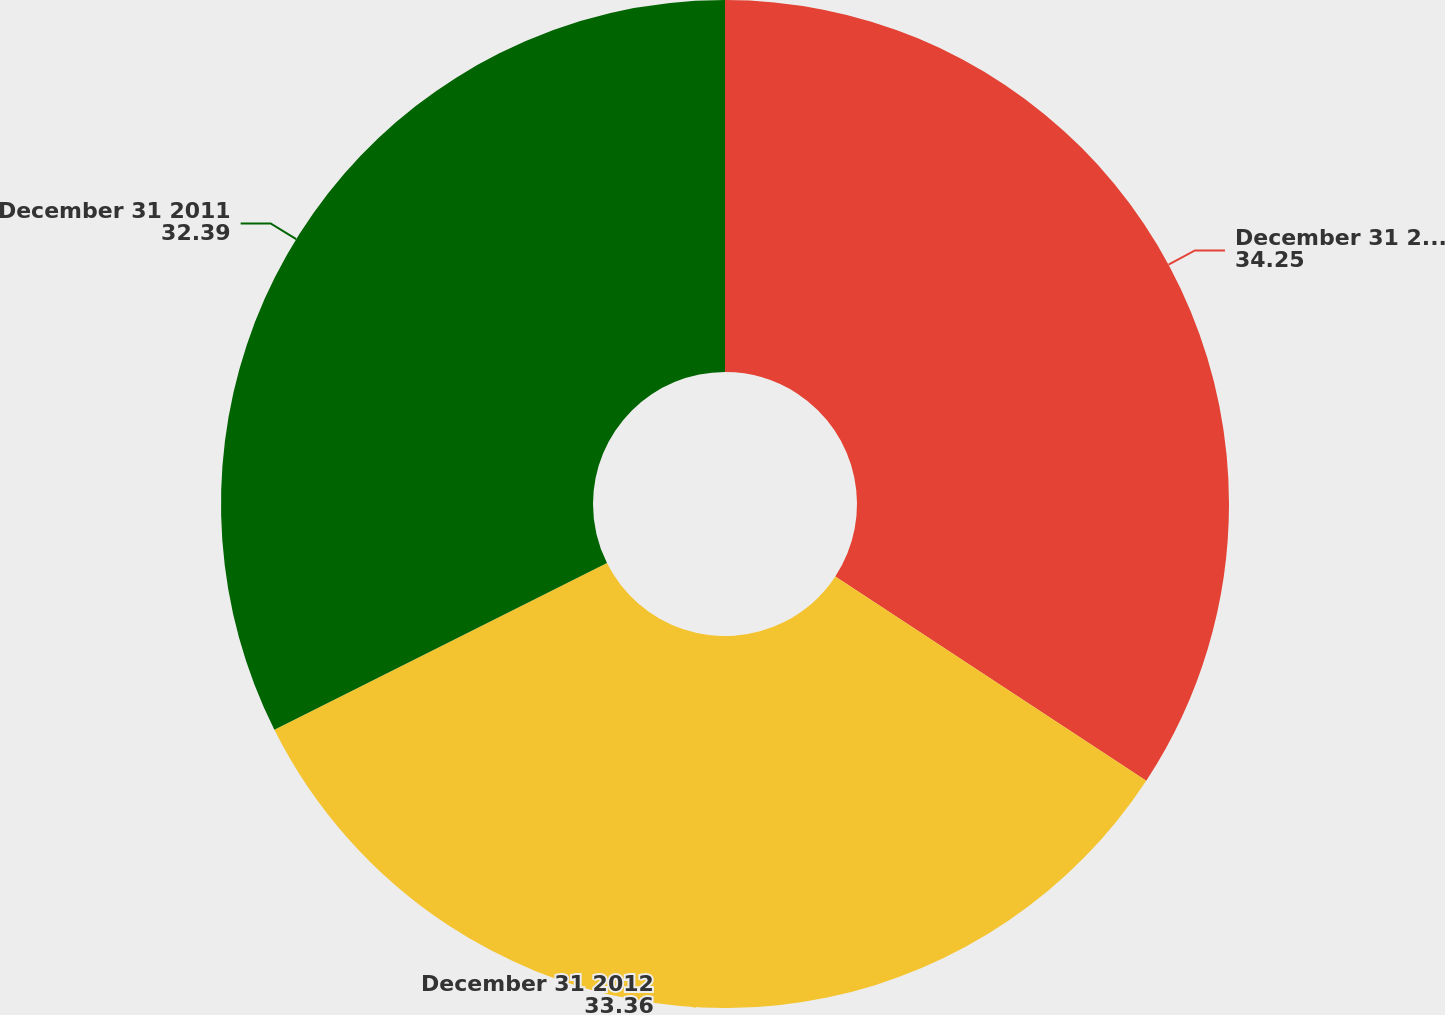Convert chart. <chart><loc_0><loc_0><loc_500><loc_500><pie_chart><fcel>December 31 2013<fcel>December 31 2012<fcel>December 31 2011<nl><fcel>34.25%<fcel>33.36%<fcel>32.39%<nl></chart> 